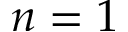Convert formula to latex. <formula><loc_0><loc_0><loc_500><loc_500>n = 1</formula> 